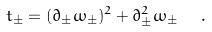Convert formula to latex. <formula><loc_0><loc_0><loc_500><loc_500>t _ { \pm } = ( \partial _ { \pm } \omega _ { \pm } ) ^ { 2 } + \partial _ { \pm } ^ { 2 } \omega _ { \pm } \ \ .</formula> 